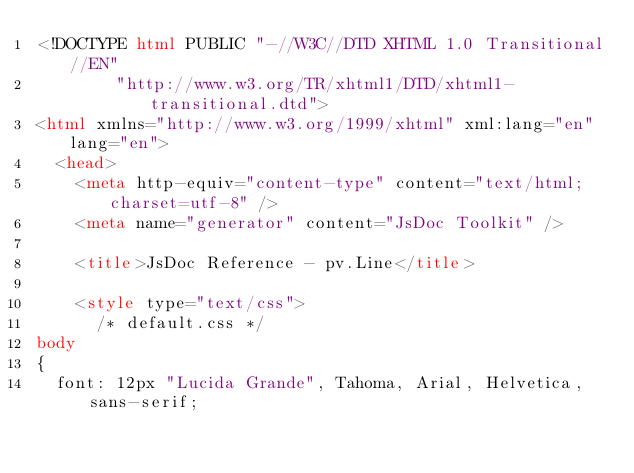<code> <loc_0><loc_0><loc_500><loc_500><_HTML_><!DOCTYPE html PUBLIC "-//W3C//DTD XHTML 1.0 Transitional//EN"
        "http://www.w3.org/TR/xhtml1/DTD/xhtml1-transitional.dtd">
<html xmlns="http://www.w3.org/1999/xhtml" xml:lang="en" lang="en">
	<head>
		<meta http-equiv="content-type" content="text/html; charset=utf-8" />
		<meta name="generator" content="JsDoc Toolkit" />
		
		<title>JsDoc Reference - pv.Line</title>

		<style type="text/css">
			/* default.css */
body
{
	font: 12px "Lucida Grande", Tahoma, Arial, Helvetica, sans-serif;</code> 